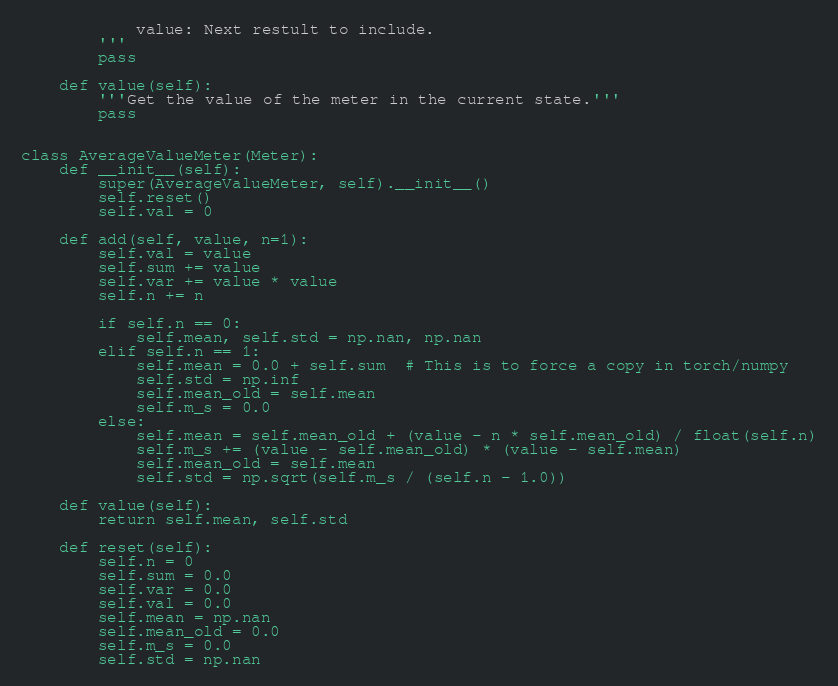Convert code to text. <code><loc_0><loc_0><loc_500><loc_500><_Python_>            value: Next restult to include.
        '''
        pass

    def value(self):
        '''Get the value of the meter in the current state.'''
        pass


class AverageValueMeter(Meter):
    def __init__(self):
        super(AverageValueMeter, self).__init__()
        self.reset()
        self.val = 0

    def add(self, value, n=1):
        self.val = value
        self.sum += value
        self.var += value * value
        self.n += n

        if self.n == 0:
            self.mean, self.std = np.nan, np.nan
        elif self.n == 1:
            self.mean = 0.0 + self.sum  # This is to force a copy in torch/numpy
            self.std = np.inf
            self.mean_old = self.mean
            self.m_s = 0.0
        else:
            self.mean = self.mean_old + (value - n * self.mean_old) / float(self.n)
            self.m_s += (value - self.mean_old) * (value - self.mean)
            self.mean_old = self.mean
            self.std = np.sqrt(self.m_s / (self.n - 1.0))

    def value(self):
        return self.mean, self.std

    def reset(self):
        self.n = 0
        self.sum = 0.0
        self.var = 0.0
        self.val = 0.0
        self.mean = np.nan
        self.mean_old = 0.0
        self.m_s = 0.0
        self.std = np.nan
</code> 